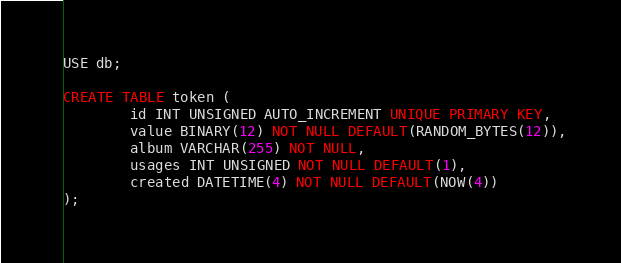<code> <loc_0><loc_0><loc_500><loc_500><_SQL_>USE db;

CREATE TABLE token (
        id INT UNSIGNED AUTO_INCREMENT UNIQUE PRIMARY KEY,
        value BINARY(12) NOT NULL DEFAULT(RANDOM_BYTES(12)),
        album VARCHAR(255) NOT NULL,
        usages INT UNSIGNED NOT NULL DEFAULT(1),
        created DATETIME(4) NOT NULL DEFAULT(NOW(4))
);
</code> 